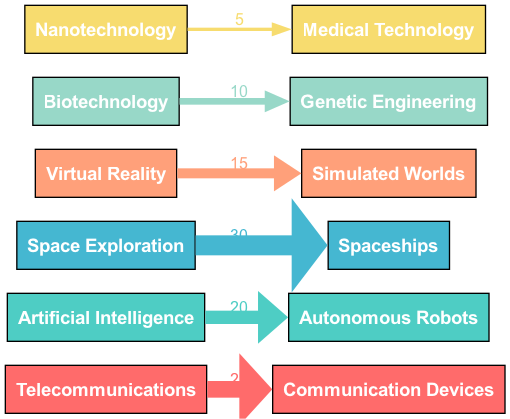What is the value associated with Space Exploration? To find the value associated with Space Exploration, locate the node representing it on the left side of the diagram and look for the connecting edge leading to Spaceships. The value indicated on this edge is the influence percentage, which is 30.
Answer: 30 Which technology leads to Autonomous Robots? Identify the source node that connects to Autonomous Robots. Tracing the edge backward shows that Artificial Intelligence is the source leading to this target.
Answer: Artificial Intelligence How many elements are represented in the diagram? Count the distinct source elements listed on the left side of the diagram. They are Telecommunications, Artificial Intelligence, Space Exploration, Virtual Reality, Biotechnology, and Nanotechnology, totaling 6 elements.
Answer: 6 What is the lowest value represented in the diagram? Review the connecting edges and their values on the diagram. The edge connecting Nanotechnology to Medical Technology has the lowest value at 5, indicating the least influence in the context of the diagram.
Answer: 5 Which invention influences Simulated Worlds? Locate the target node for Simulated Worlds and trace its connection back to the source node. The edge leading to Simulated Worlds indicates that Virtual Reality is the invention influencing it.
Answer: Virtual Reality What percentage of influence does Biotechnology have? Find the edge connecting Biotechnology to its target, which is Genetic Engineering. The value on this edge indicates that Biotechnology has an influence percentage of 10 in the storyline context.
Answer: 10 What is the total influence value accounted for in the diagram? To get the total influence value, sum the values of all edges. Add the values: 25 (Telecommunications) + 20 (Artificial Intelligence) + 30 (Space Exploration) + 15 (Virtual Reality) + 10 (Biotechnology) + 5 (Nanotechnology). The total equals 105.
Answer: 105 Which source has the highest value, and what is that value? Scan through the edges to find the highest value connecting a source to its target. The edge for Space Exploration to Spaceships represents the highest value indicated by 30.
Answer: Space Exploration, 30 What color is associated with the edge from Telecommunications? Look at the diagram and see the color assigned to the edge leading from Telecommunications to Communication Devices. It is represented in light red (#FF6B6B).
Answer: #FF6B6B 